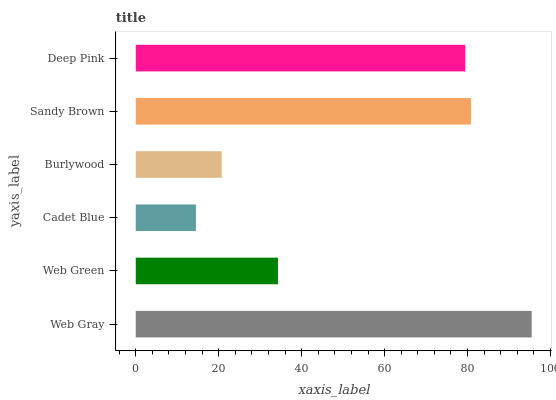Is Cadet Blue the minimum?
Answer yes or no. Yes. Is Web Gray the maximum?
Answer yes or no. Yes. Is Web Green the minimum?
Answer yes or no. No. Is Web Green the maximum?
Answer yes or no. No. Is Web Gray greater than Web Green?
Answer yes or no. Yes. Is Web Green less than Web Gray?
Answer yes or no. Yes. Is Web Green greater than Web Gray?
Answer yes or no. No. Is Web Gray less than Web Green?
Answer yes or no. No. Is Deep Pink the high median?
Answer yes or no. Yes. Is Web Green the low median?
Answer yes or no. Yes. Is Web Green the high median?
Answer yes or no. No. Is Deep Pink the low median?
Answer yes or no. No. 